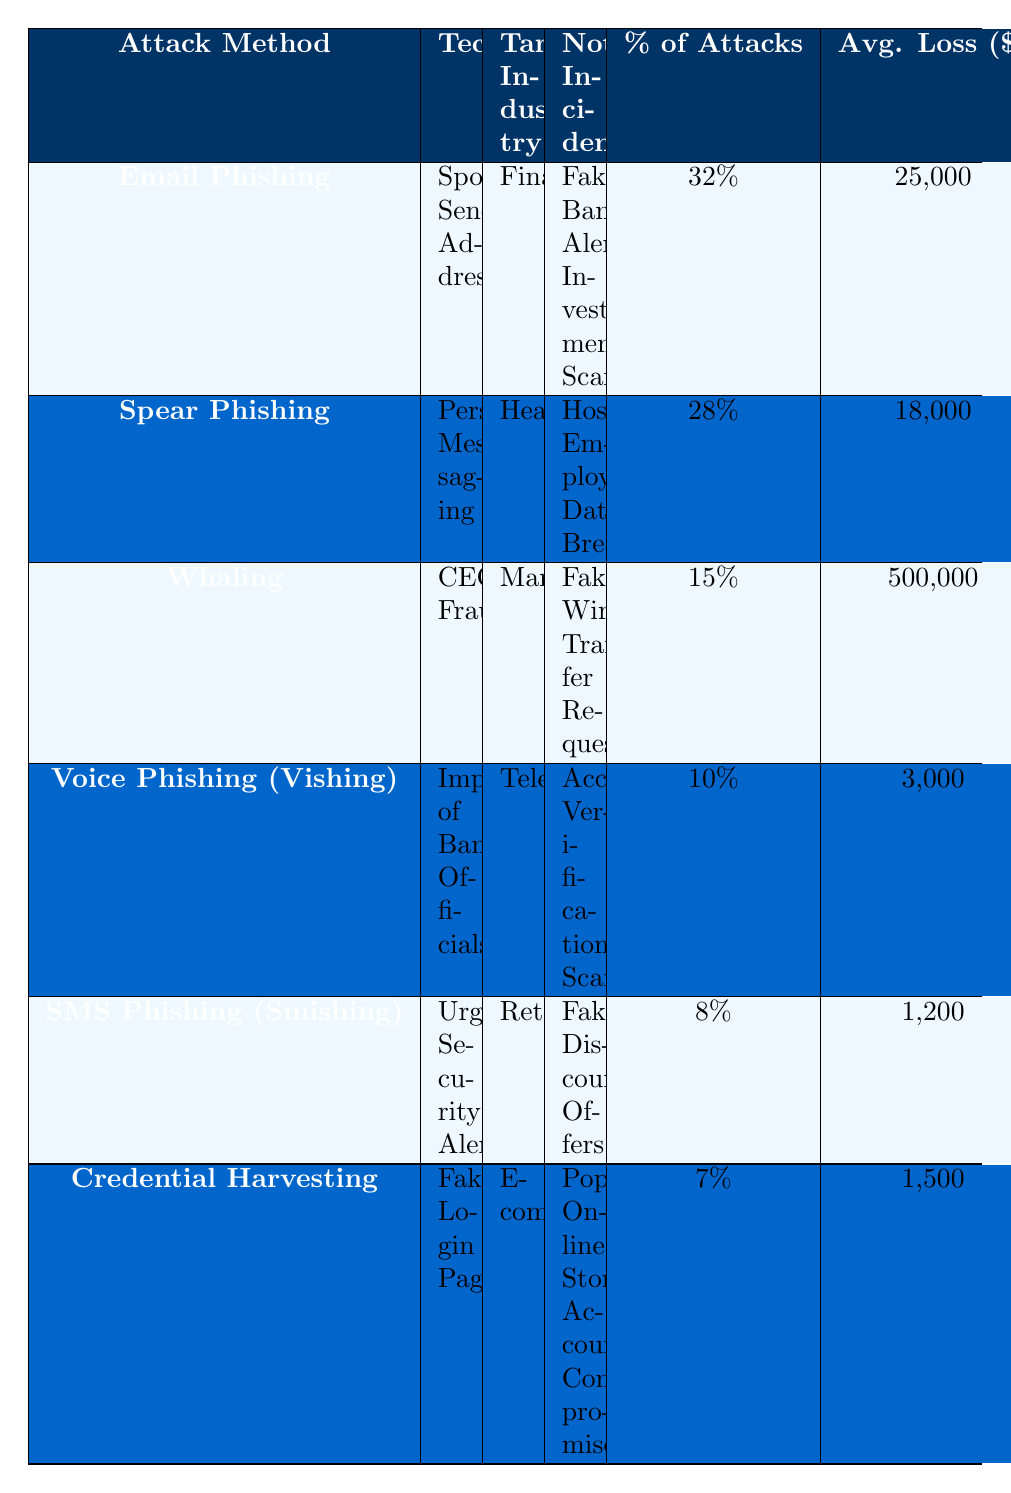What is the target industry with the highest percentage of phishing attacks? In the table, "Email Phishing" in the Finance industry has the highest percentage of attacks at 32%.
Answer: Finance What technique is used in the majority of attacks targeting the Healthcare industry? In Healthcare, the technique used is "Personalized Messaging" in Spear Phishing, which corresponds to 28% of attacks.
Answer: Personalized Messaging How much is the average loss per attack in the Manufacturing industry? The average loss per attack in the Manufacturing industry (Whaling with the technique CEO Fraud) is $500,000.
Answer: 500,000 Is SMS Phishing (Smishing) used more widely than Credential Harvesting? Yes, SMS Phishing (Smishing) at 8% of attacks has a higher percentage of usage compared to Credential Harvesting, which accounts for 7%.
Answer: Yes What percentage of attacks does the Retail industry experience through SMS Phishing (Smishing)? The Retail industry experiences 8% of attacks through SMS Phishing (Smishing).
Answer: 8% Which attack method has the lowest number of average loss per attack? Credential Harvesting has the lowest average loss per attack at $1,500.
Answer: 1,500 What is the total percentage of attacks that occur in the Finance and Healthcare industries combined? The total percentage for Finance (32%) and Healthcare (28%) is 32% + 28% = 60%.
Answer: 60% From the data presented, what can be inferred about the relationship between attack methods and target industries? Phishing attack methods target specific industries; for instance, Email Phishing is significant in Finance, while Whaling targets Manufacturing, indicating a tailored approach to attacks based on industry vulnerabilities.
Answer: Tailored approach based on industry vulnerabilities What notable incident is associated with Voice Phishing (Vishing)? The notable incident associated with Voice Phishing (Vishing) is "Account Verification Scams."
Answer: Account Verification Scams Based on the data, which attack method has the highest average loss per attack, and what is that amount? Whaling has the highest average loss per attack at $500,000.
Answer: 500,000 